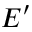Convert formula to latex. <formula><loc_0><loc_0><loc_500><loc_500>E ^ { \prime }</formula> 